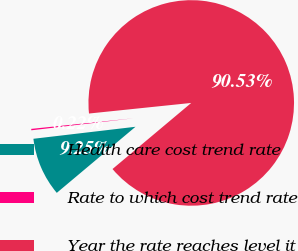<chart> <loc_0><loc_0><loc_500><loc_500><pie_chart><fcel>Health care cost trend rate<fcel>Rate to which cost trend rate<fcel>Year the rate reaches level it<nl><fcel>9.25%<fcel>0.22%<fcel>90.52%<nl></chart> 